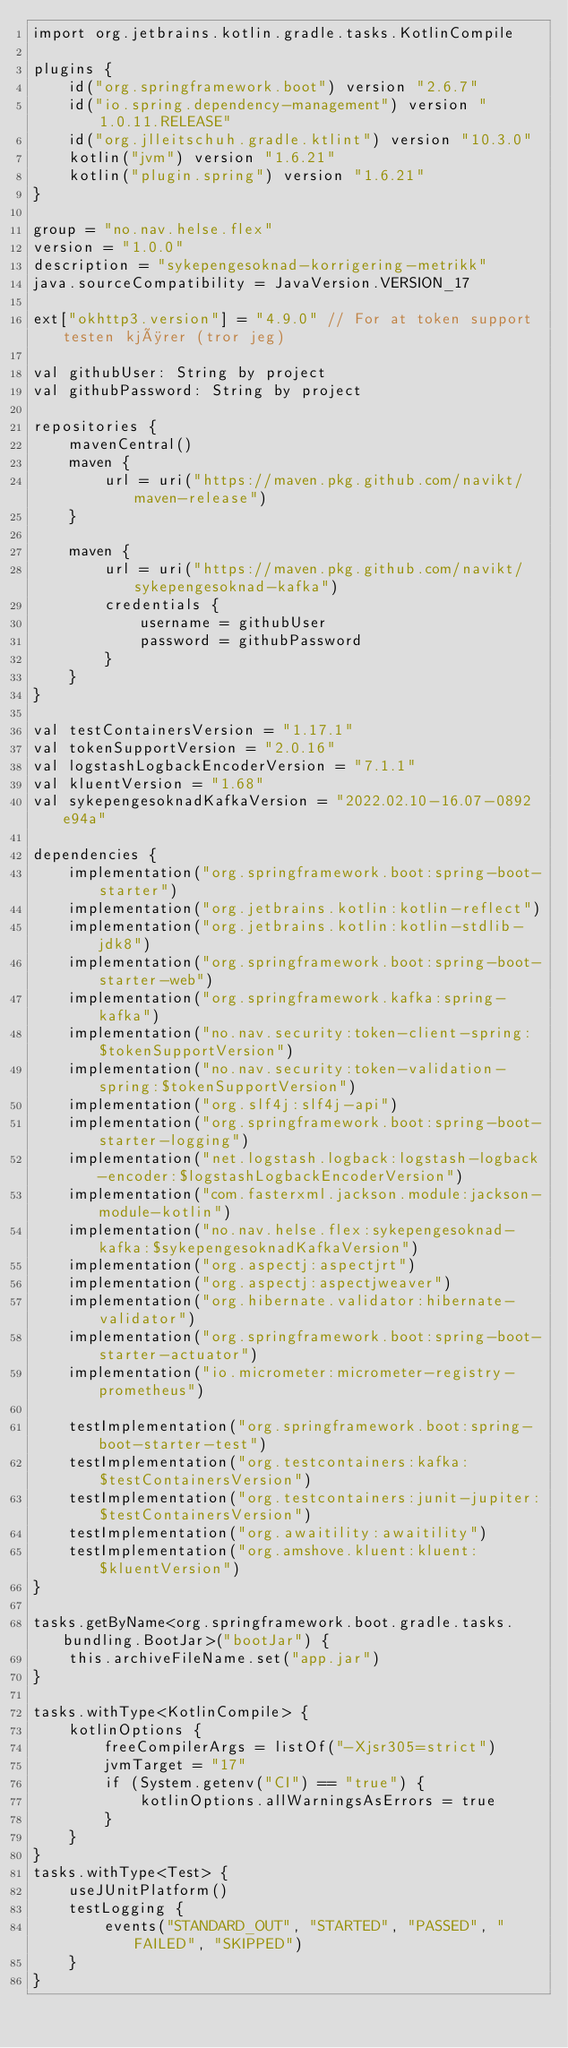Convert code to text. <code><loc_0><loc_0><loc_500><loc_500><_Kotlin_>import org.jetbrains.kotlin.gradle.tasks.KotlinCompile

plugins {
    id("org.springframework.boot") version "2.6.7"
    id("io.spring.dependency-management") version "1.0.11.RELEASE"
    id("org.jlleitschuh.gradle.ktlint") version "10.3.0"
    kotlin("jvm") version "1.6.21"
    kotlin("plugin.spring") version "1.6.21"
}

group = "no.nav.helse.flex"
version = "1.0.0"
description = "sykepengesoknad-korrigering-metrikk"
java.sourceCompatibility = JavaVersion.VERSION_17

ext["okhttp3.version"] = "4.9.0" // For at token support testen kjører (tror jeg)

val githubUser: String by project
val githubPassword: String by project

repositories {
    mavenCentral()
    maven {
        url = uri("https://maven.pkg.github.com/navikt/maven-release")
    }

    maven {
        url = uri("https://maven.pkg.github.com/navikt/sykepengesoknad-kafka")
        credentials {
            username = githubUser
            password = githubPassword
        }
    }
}

val testContainersVersion = "1.17.1"
val tokenSupportVersion = "2.0.16"
val logstashLogbackEncoderVersion = "7.1.1"
val kluentVersion = "1.68"
val sykepengesoknadKafkaVersion = "2022.02.10-16.07-0892e94a"

dependencies {
    implementation("org.springframework.boot:spring-boot-starter")
    implementation("org.jetbrains.kotlin:kotlin-reflect")
    implementation("org.jetbrains.kotlin:kotlin-stdlib-jdk8")
    implementation("org.springframework.boot:spring-boot-starter-web")
    implementation("org.springframework.kafka:spring-kafka")
    implementation("no.nav.security:token-client-spring:$tokenSupportVersion")
    implementation("no.nav.security:token-validation-spring:$tokenSupportVersion")
    implementation("org.slf4j:slf4j-api")
    implementation("org.springframework.boot:spring-boot-starter-logging")
    implementation("net.logstash.logback:logstash-logback-encoder:$logstashLogbackEncoderVersion")
    implementation("com.fasterxml.jackson.module:jackson-module-kotlin")
    implementation("no.nav.helse.flex:sykepengesoknad-kafka:$sykepengesoknadKafkaVersion")
    implementation("org.aspectj:aspectjrt")
    implementation("org.aspectj:aspectjweaver")
    implementation("org.hibernate.validator:hibernate-validator")
    implementation("org.springframework.boot:spring-boot-starter-actuator")
    implementation("io.micrometer:micrometer-registry-prometheus")

    testImplementation("org.springframework.boot:spring-boot-starter-test")
    testImplementation("org.testcontainers:kafka:$testContainersVersion")
    testImplementation("org.testcontainers:junit-jupiter:$testContainersVersion")
    testImplementation("org.awaitility:awaitility")
    testImplementation("org.amshove.kluent:kluent:$kluentVersion")
}

tasks.getByName<org.springframework.boot.gradle.tasks.bundling.BootJar>("bootJar") {
    this.archiveFileName.set("app.jar")
}

tasks.withType<KotlinCompile> {
    kotlinOptions {
        freeCompilerArgs = listOf("-Xjsr305=strict")
        jvmTarget = "17"
        if (System.getenv("CI") == "true") {
            kotlinOptions.allWarningsAsErrors = true
        }
    }
}
tasks.withType<Test> {
    useJUnitPlatform()
    testLogging {
        events("STANDARD_OUT", "STARTED", "PASSED", "FAILED", "SKIPPED")
    }
}
</code> 